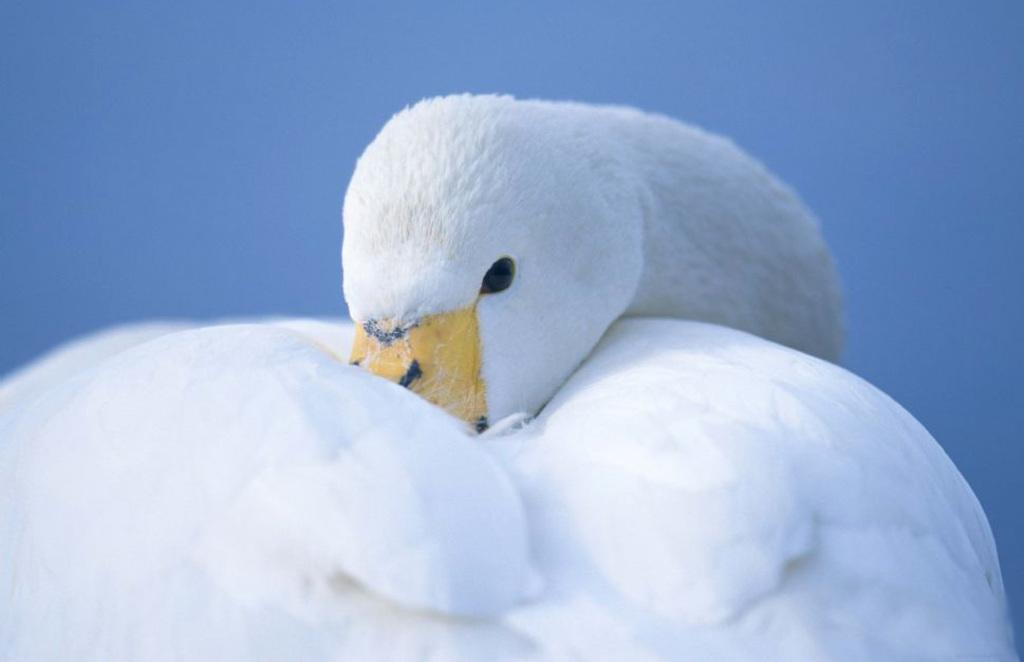What animal is present in the image? There is a swan in the image. What is the color of the swan? The swan is white in color. What can be seen in the background of the image? The background of the image is blue in color. Reasoning: Let'g: Let's think step by step in order to produce the conversation. We start by identifying the main subject in the image, which is the swan. Then, we describe the color of the swan, which is white. Finally, we mention the background color of the image, which is blue. Each question is designed to elicit a specific detail about the image that is known from the provided facts. Absurd Question/Answer: What songs is the swan singing in the image? Swans do not sing songs, so there is no singing in the image. 